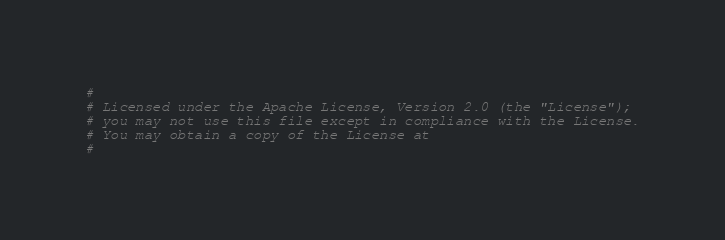<code> <loc_0><loc_0><loc_500><loc_500><_Perl_>#
# Licensed under the Apache License, Version 2.0 (the "License");
# you may not use this file except in compliance with the License.
# You may obtain a copy of the License at
#</code> 